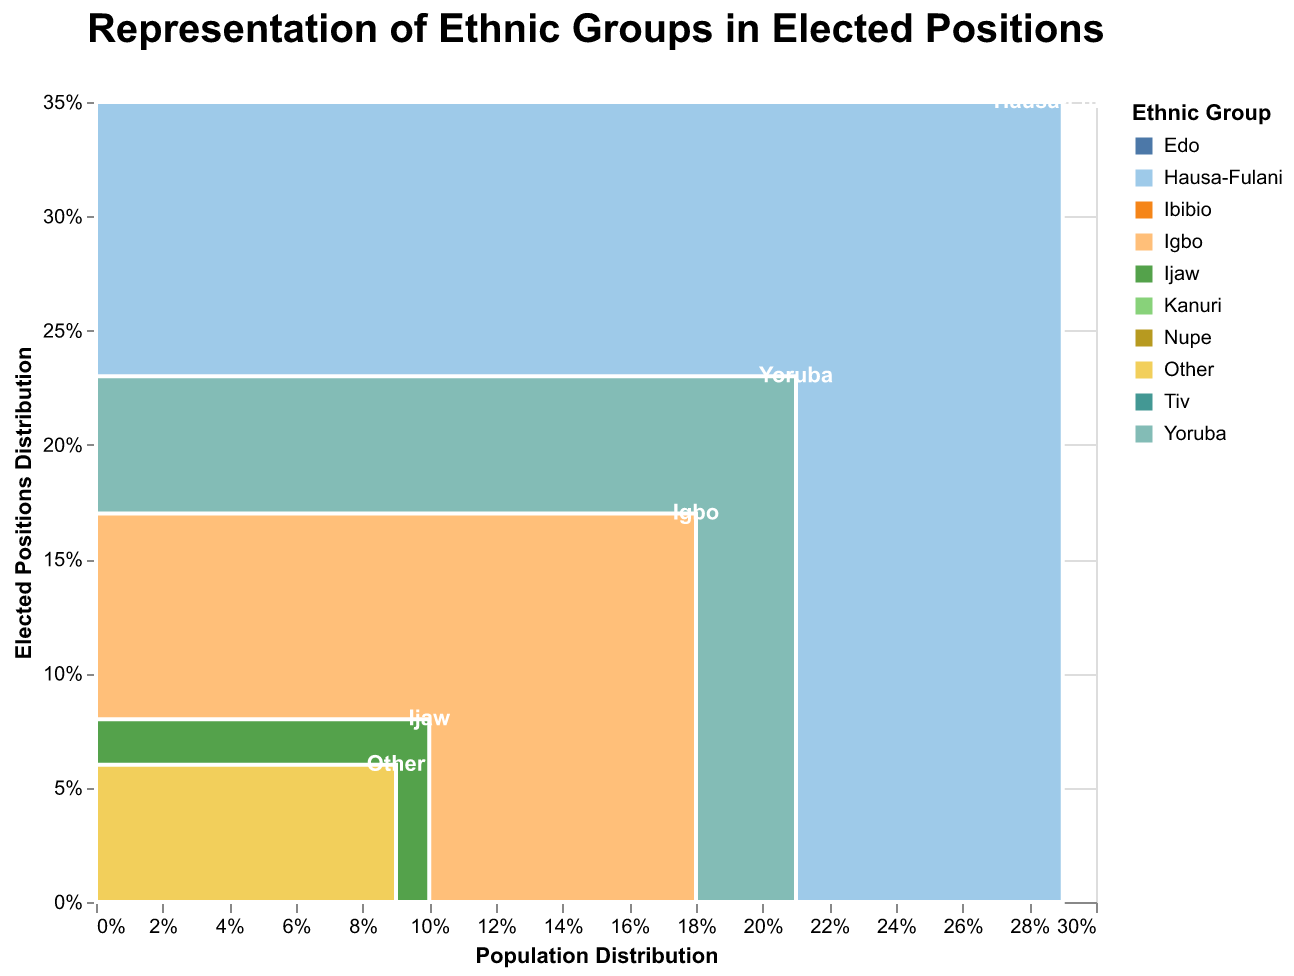What is the title of the plot? The title of the plot is clearly written at the top and states: "Representation of Ethnic Groups in Elected Positions."
Answer: Representation of Ethnic Groups in Elected Positions Which ethnic group has the highest representation in elected positions? The ethnic group with the highest representation in elected positions can be identified by looking for the highest percentage in the "Elected Positions Distribution" axis. The Hausa-Fulani group has the highest elected percentage at 35%.
Answer: Hausa-Fulani How does the Yoruba group's representation in the population compare to their elected positions? To answer this, compare the Yoruba group's position on the "Population Distribution" axis and the "Elected Positions Distribution" axis. Yoruba has 21% in the population and 23% in elected positions.
Answer: Yoruba is 2% higher in elected positions compared to their population What is the difference between the Igbo population percentage and their elected positions percentage? To find the difference, subtract the elected positions percentage from the population percentage for the Igbo group. This is calculated as 18% - 17% = 1%.
Answer: 1% Which ethnic group shows the largest disparity between population percentage and elected positions percentage? Calculate the disparity by subtracting the population percentage from the elected positions percentage for all groups, and identify the largest difference. The Hausa-Fulani show the largest disparity with a difference of 6% (35% - 29%).
Answer: Hausa-Fulani What is the total percentage of elected positions held by the groups classified as 'Other'? The 'Other' group shows their percentage directly on the "Elected Positions Distribution" axis, which is 6%.
Answer: 6% Which ethnic groups have both their population percentage and elected positions percentage below 5%? Look for ethnic groups that appear below the 5% mark on both the "Population Distribution" and "Elected Positions Distribution" axes. These groups are Kanuri (4% and 3%), Ibibio (3.5% and 3%), Tiv (2.5% and 2%), Edo (2% and 2%), and Nupe (1% and 1%).
Answer: Kanuri, Ibibio, Tiv, Edo, Nupe Is there any ethnic group that has an equal percentage of population and elected positions? Check if there are any ethnic groups where the bars align exactly on both axes. Edo and Nupe both have equal percentages in both population and elected positions, at 2% and 1% respectively.
Answer: Edo, Nupe How many ethnic groups have a higher percentage of elected positions compared to their population percentage? Identify ethnic groups where the "Elected Positions Distribution" percentage is greater than the "Population Distribution" percentage. Hausa-Fulani (29% vs 35%) and Yoruba (21% vs 23%) fit this criterion.
Answer: 2 groups (Hausa-Fulani, Yoruba) What is the combined percentage of the population for the ethnic groups that have less than 10% population each? Sum the population percentages for Kanuri, Ibibio, Tiv, Edo, Nupe, and Other groups. This is 4% + 3.5% + 2.5% + 2% + 1% + 9% = 22%.
Answer: 22% 